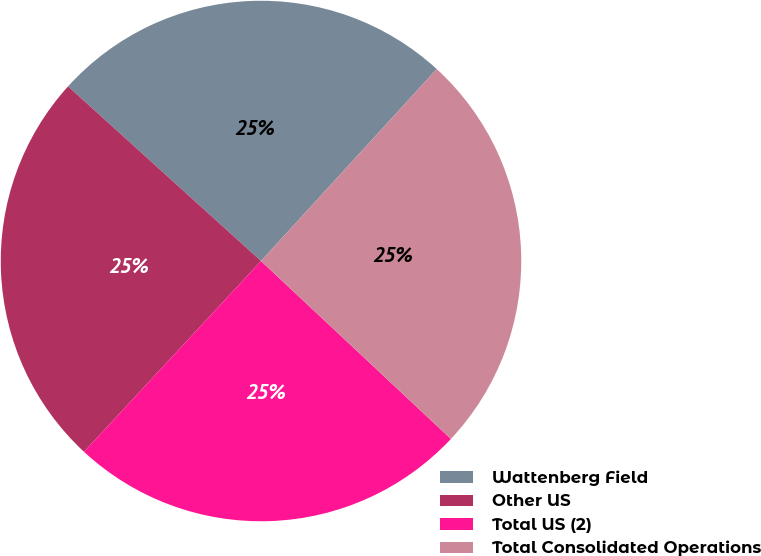Convert chart. <chart><loc_0><loc_0><loc_500><loc_500><pie_chart><fcel>Wattenberg Field<fcel>Other US<fcel>Total US (2)<fcel>Total Consolidated Operations<nl><fcel>25.09%<fcel>24.8%<fcel>24.92%<fcel>25.18%<nl></chart> 